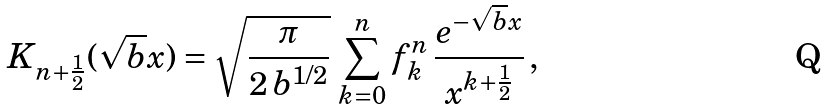Convert formula to latex. <formula><loc_0><loc_0><loc_500><loc_500>K _ { n + \frac { 1 } { 2 } } ( \sqrt { b } x ) = \sqrt { \frac { \pi } { 2 \, b ^ { 1 / 2 } } } \, \sum _ { k = 0 } ^ { n } f _ { k } ^ { n } \, \frac { e ^ { - \sqrt { b } x } } { x ^ { k + \frac { 1 } { 2 } } } \, ,</formula> 